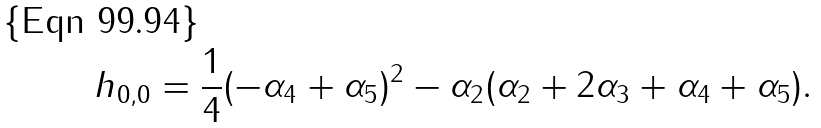<formula> <loc_0><loc_0><loc_500><loc_500>h _ { 0 , 0 } = \frac { 1 } { 4 } ( - \alpha _ { 4 } + \alpha _ { 5 } ) ^ { 2 } - \alpha _ { 2 } ( \alpha _ { 2 } + 2 \alpha _ { 3 } + \alpha _ { 4 } + \alpha _ { 5 } ) .</formula> 